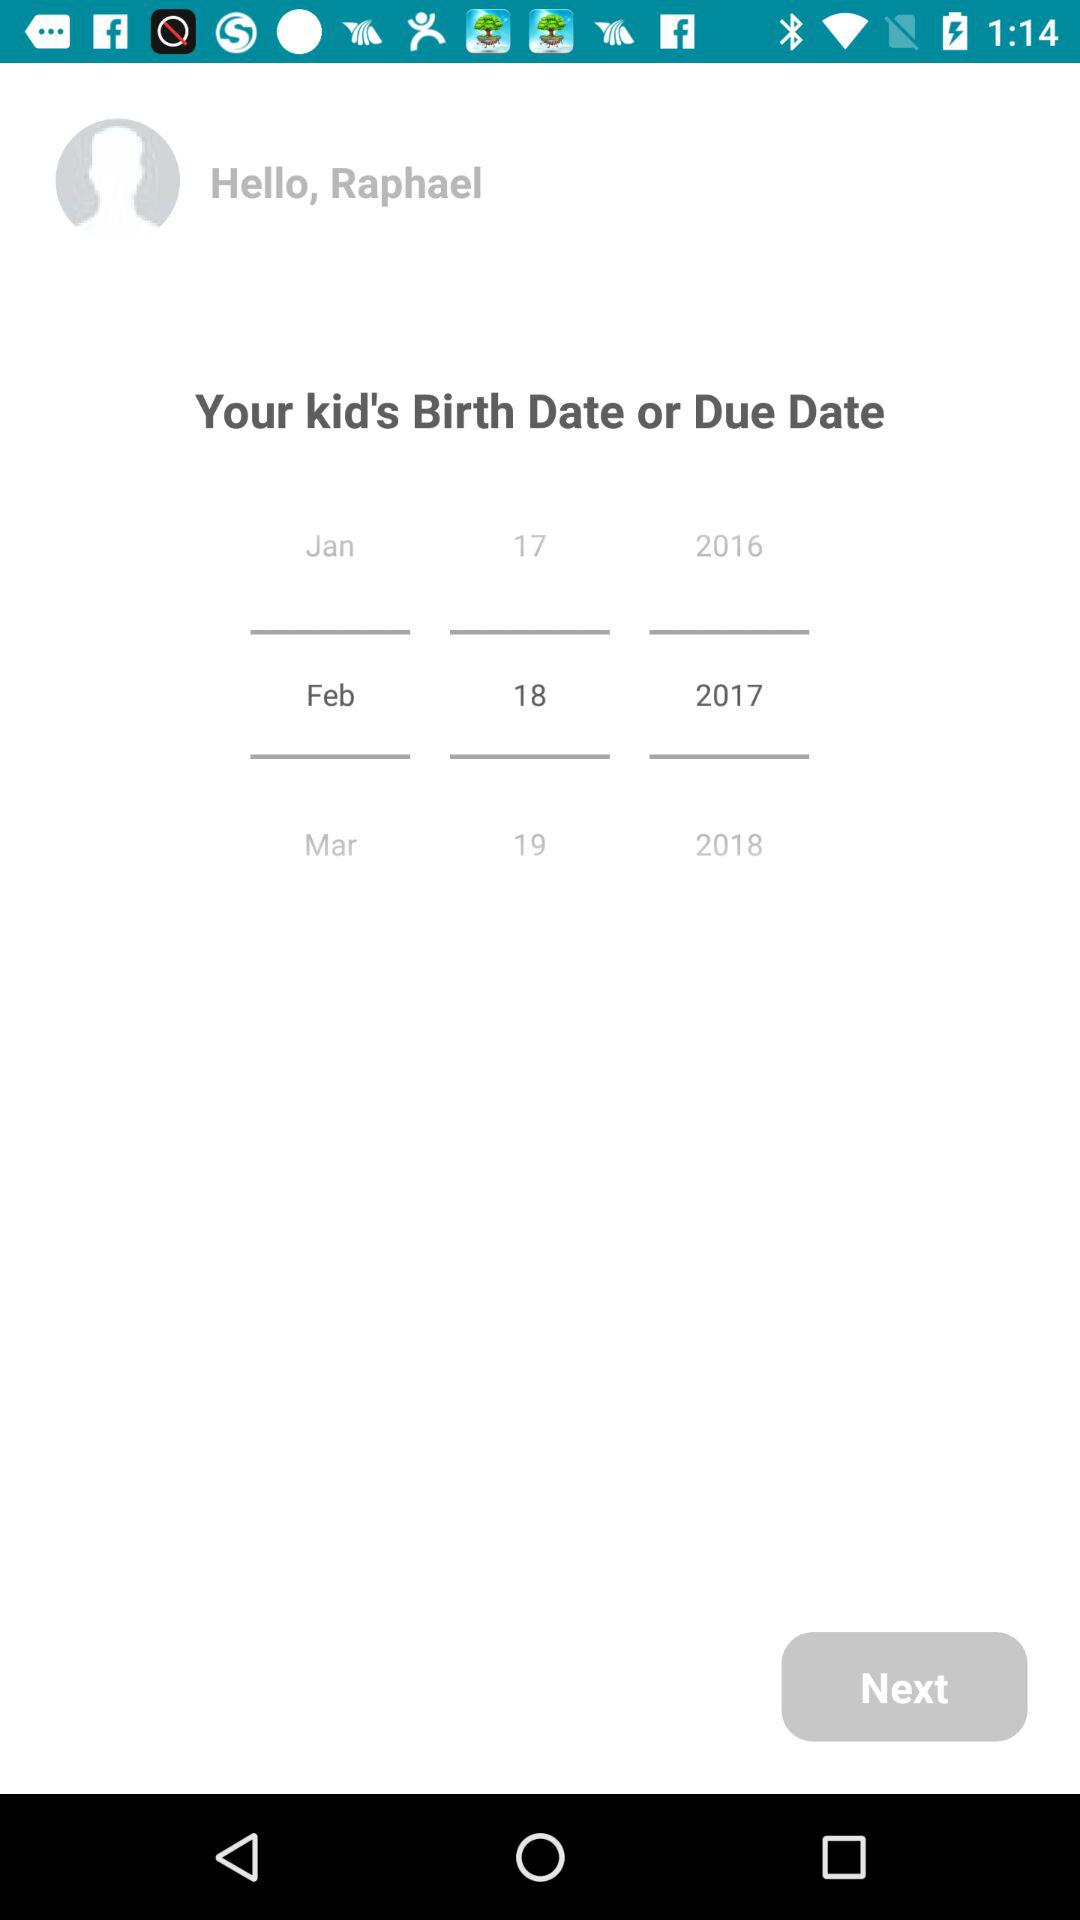What is the profile name? The profile name is Raphael. 